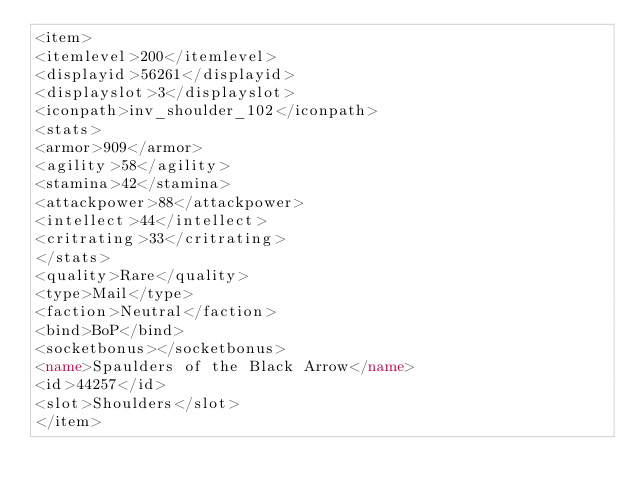Convert code to text. <code><loc_0><loc_0><loc_500><loc_500><_XML_><item>
<itemlevel>200</itemlevel>
<displayid>56261</displayid>
<displayslot>3</displayslot>
<iconpath>inv_shoulder_102</iconpath>
<stats>
<armor>909</armor>
<agility>58</agility>
<stamina>42</stamina>
<attackpower>88</attackpower>
<intellect>44</intellect>
<critrating>33</critrating>
</stats>
<quality>Rare</quality>
<type>Mail</type>
<faction>Neutral</faction>
<bind>BoP</bind>
<socketbonus></socketbonus>
<name>Spaulders of the Black Arrow</name>
<id>44257</id>
<slot>Shoulders</slot>
</item></code> 